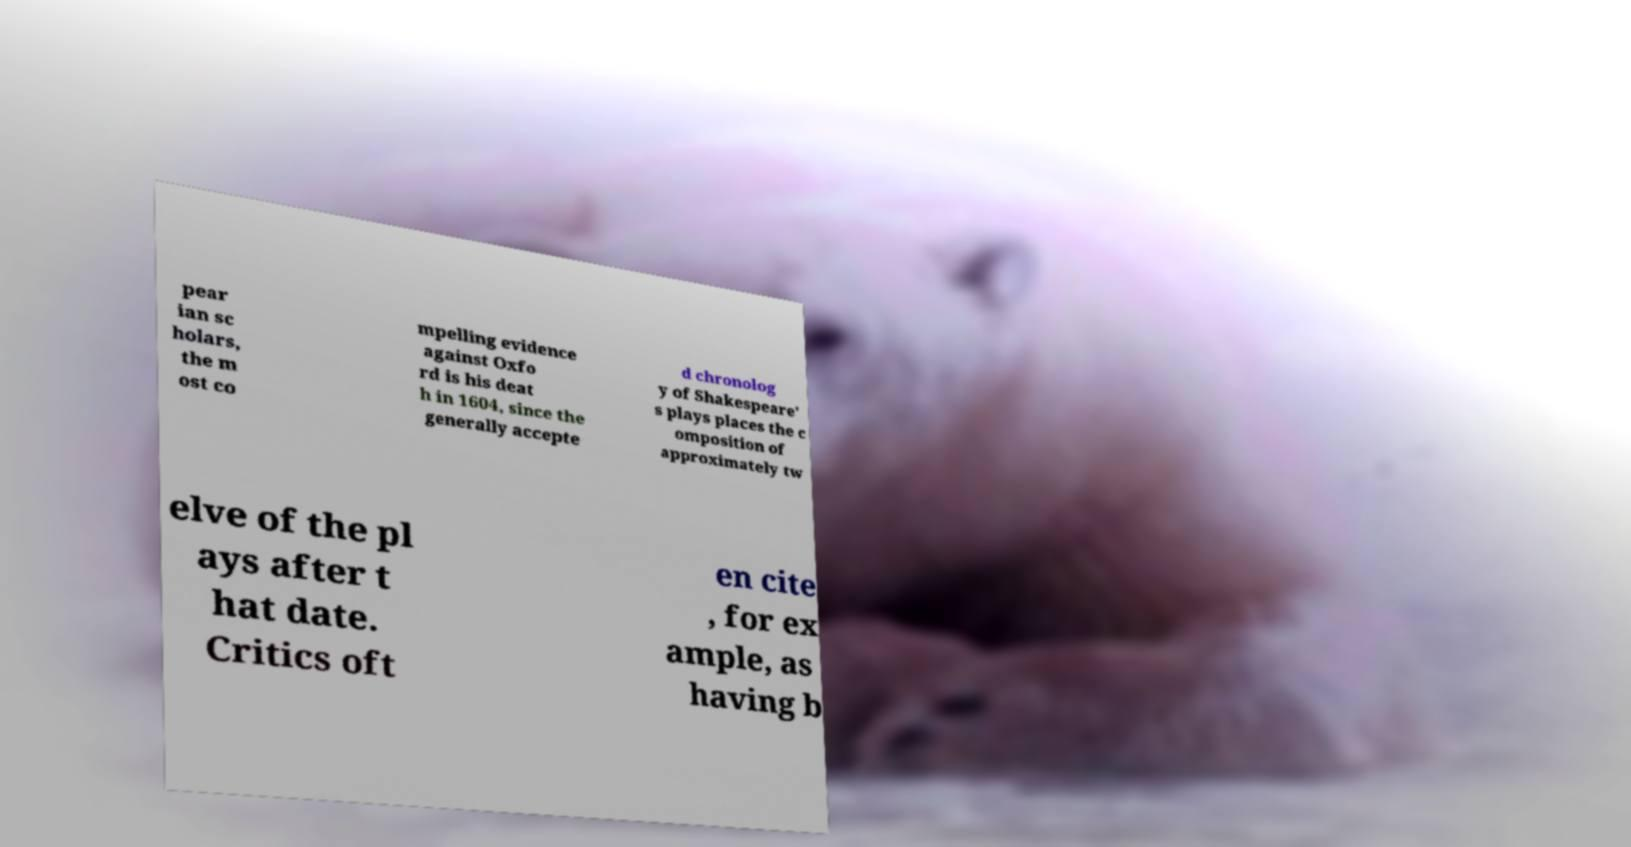Please read and relay the text visible in this image. What does it say? pear ian sc holars, the m ost co mpelling evidence against Oxfo rd is his deat h in 1604, since the generally accepte d chronolog y of Shakespeare' s plays places the c omposition of approximately tw elve of the pl ays after t hat date. Critics oft en cite , for ex ample, as having b 